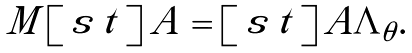Convert formula to latex. <formula><loc_0><loc_0><loc_500><loc_500>\begin{array} { c } M \left [ \begin{array} { c } { s } \, { t } \end{array} \right ] A = \left [ \begin{array} { c } { s } \, { t } \end{array} \right ] A \Lambda _ { \theta } . \end{array}</formula> 